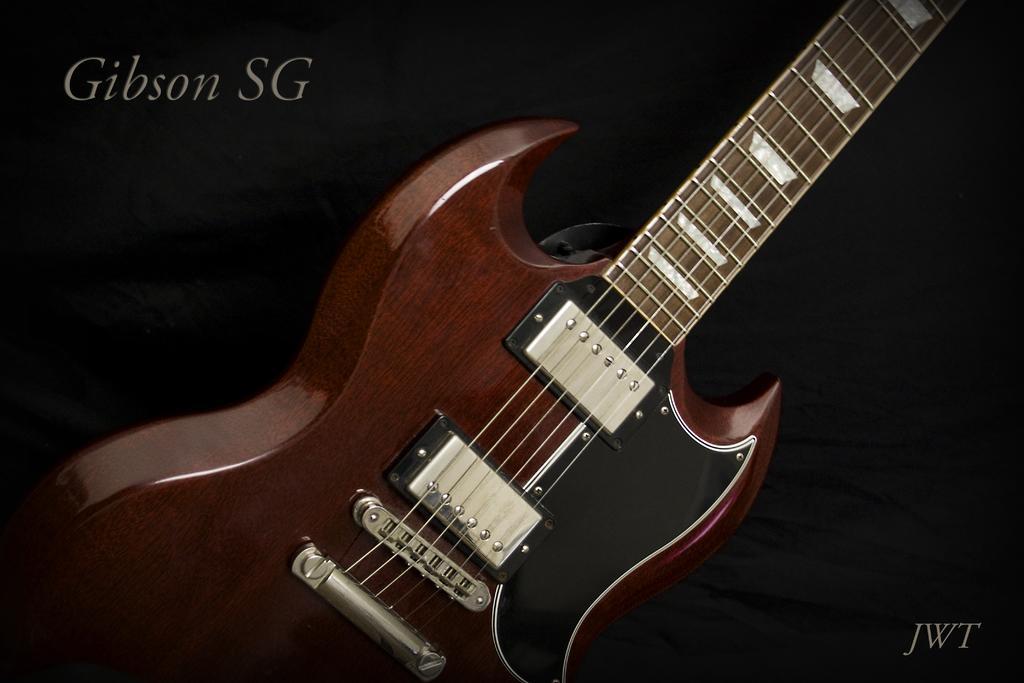Can you describe this image briefly? In this image there is a guitar. 